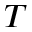Convert formula to latex. <formula><loc_0><loc_0><loc_500><loc_500>T</formula> 